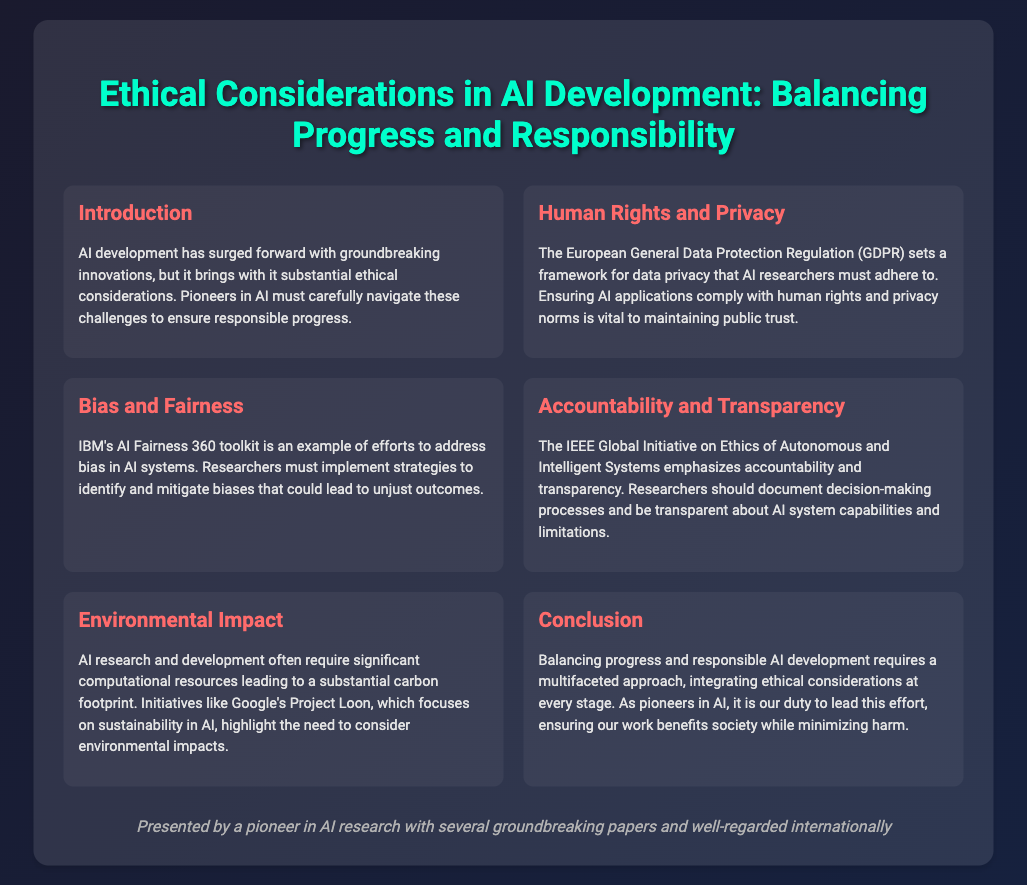What is the title of the presentation? The title is prominently displayed at the top of the slide, summarizing the topic of the presentation.
Answer: Ethical Considerations in AI Development: Balancing Progress and Responsibility What toolkit does IBM offer to address bias in AI systems? This is mentioned under the "Bias and Fairness" section, highlighting efforts made to tackle bias issues.
Answer: AI Fairness 360 toolkit What regulation must AI researchers adhere to concerning data privacy? The document specifies a regulation under the "Human Rights and Privacy" section that guides data privacy standards.
Answer: GDPR What initiative emphasizes accountability and transparency in AI research? This is mentioned in the "Accountability and Transparency" section, pointing to an organization that guides ethical practices.
Answer: IEEE Global Initiative on Ethics of Autonomous and Intelligent Systems Which project highlights the environmental sustainability in AI? This project is referenced under the "Environmental Impact" section, relating to sustainability efforts within AI research.
Answer: Project Loon What is the primary duty of AI pioneers according to the conclusion? The conclusion summarizes the responsibilities of individuals in AI research concerning societal benefit and harm minimization.
Answer: Lead this effort 